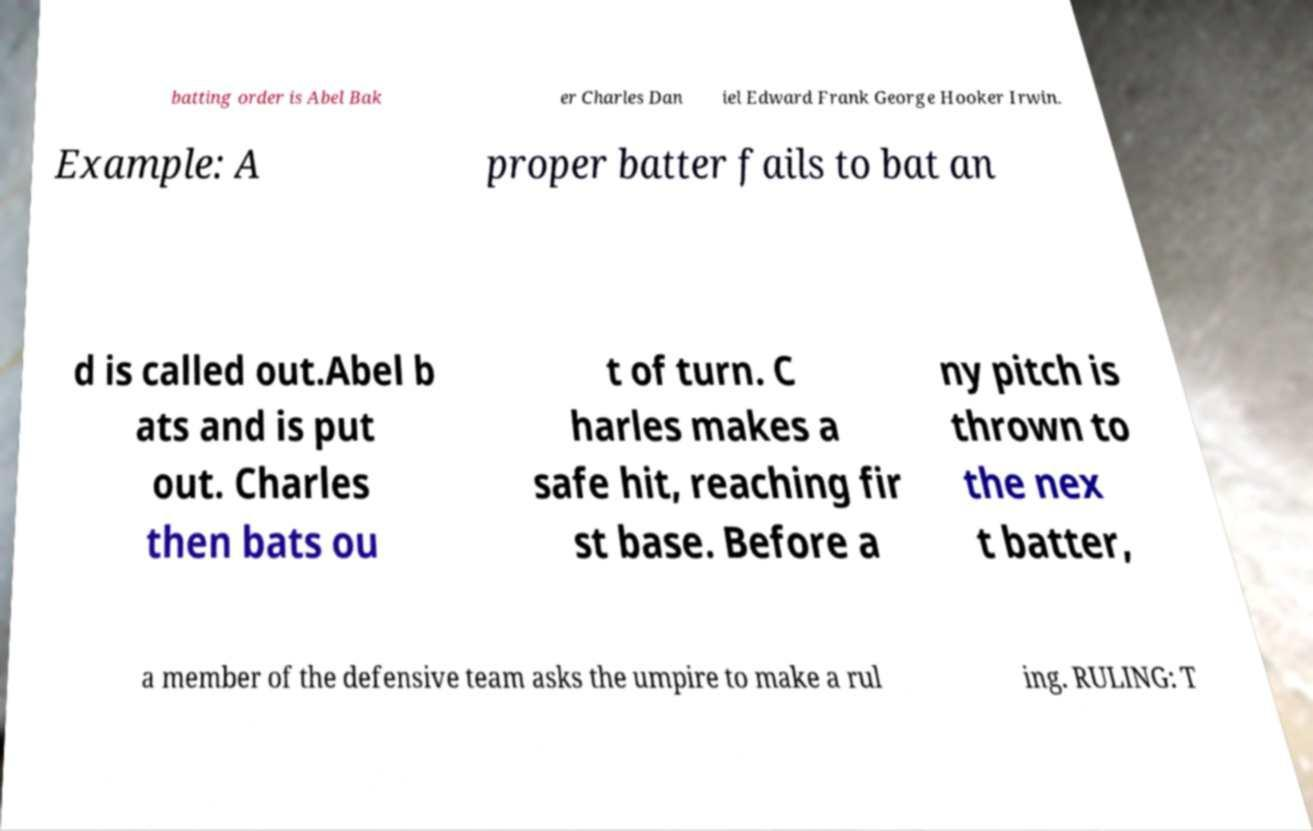Can you read and provide the text displayed in the image?This photo seems to have some interesting text. Can you extract and type it out for me? batting order is Abel Bak er Charles Dan iel Edward Frank George Hooker Irwin. Example: A proper batter fails to bat an d is called out.Abel b ats and is put out. Charles then bats ou t of turn. C harles makes a safe hit, reaching fir st base. Before a ny pitch is thrown to the nex t batter, a member of the defensive team asks the umpire to make a rul ing. RULING: T 